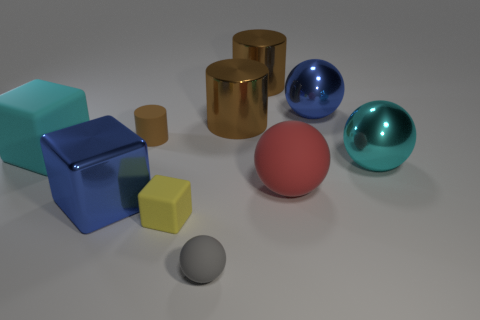What can you infer about the light source in this image? Judging by the shadows and highlights on the objects, it appears that there is a single light source coming from the upper left of the scene. The shadows fall towards the right and slightly forward, indicating the light direction and placement. 